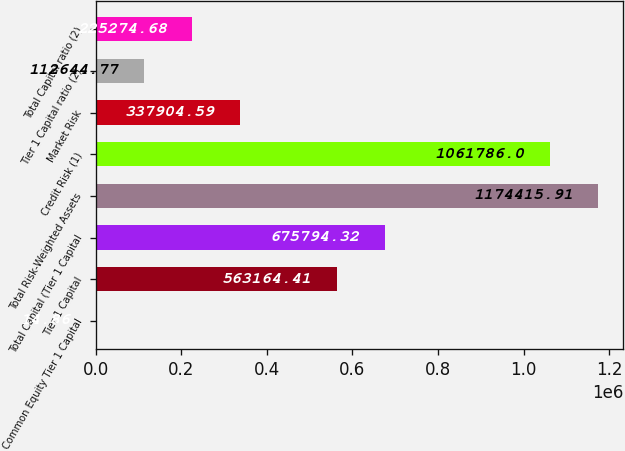<chart> <loc_0><loc_0><loc_500><loc_500><bar_chart><fcel>Common Equity Tier 1 Capital<fcel>Tier 1 Capital<fcel>Total Capital (Tier 1 Capital<fcel>Total Risk-Weighted Assets<fcel>Credit Risk (1)<fcel>Market Risk<fcel>Tier 1 Capital ratio (2)<fcel>Total Capital ratio (2)<nl><fcel>14.86<fcel>563164<fcel>675794<fcel>1.17442e+06<fcel>1.06179e+06<fcel>337905<fcel>112645<fcel>225275<nl></chart> 